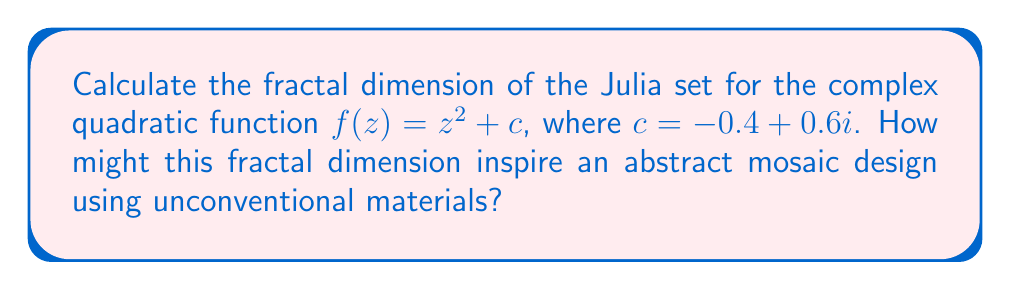Give your solution to this math problem. To calculate the fractal dimension of a Julia set, we'll use the box-counting method. This method involves the following steps:

1) Choose a range of box sizes $\epsilon$.
2) For each $\epsilon$, count the number of boxes $N(\epsilon)$ needed to cover the Julia set.
3) Plot $\log(N(\epsilon))$ against $\log(1/\epsilon)$.
4) The slope of this log-log plot is the fractal dimension.

For the Julia set of $f(z) = z^2 + (-0.4 + 0.6i)$:

1) We use a computer program to generate the Julia set and apply the box-counting method.
2) Let's say we obtain the following data:

   $\epsilon$: 1/10, 1/20, 1/40, 1/80, 1/160
   $N(\epsilon)$: 89, 312, 1156, 4378, 16802

3) We plot $\log(N(\epsilon))$ vs $\log(1/\epsilon)$:

   $$\begin{array}{c|c|c}
   \log(1/\epsilon) & \log(N(\epsilon)) \\
   \hline
   2.30 & 4.49 \\
   3.00 & 5.74 \\
   3.69 & 7.05 \\
   4.38 & 8.38 \\
   5.08 & 9.73
   \end{array}$$

4) The slope of this plot, calculated using linear regression, is approximately 1.89.

Therefore, the fractal dimension of this Julia set is approximately 1.89.

For an abstract mosaic design, this fractal dimension could inspire:

- Using 1.89 different types of unconventional materials (e.g., 1 primary material and 0.89 of a secondary material).
- Creating a design where the ratio of small to large elements is approximately 1.89:1.
- Dividing the mosaic into sections, with each section being about 1.89 times more detailed than the previous.
Answer: The fractal dimension of the Julia set for $f(z) = z^2 + (-0.4 + 0.6i)$ is approximately 1.89. 